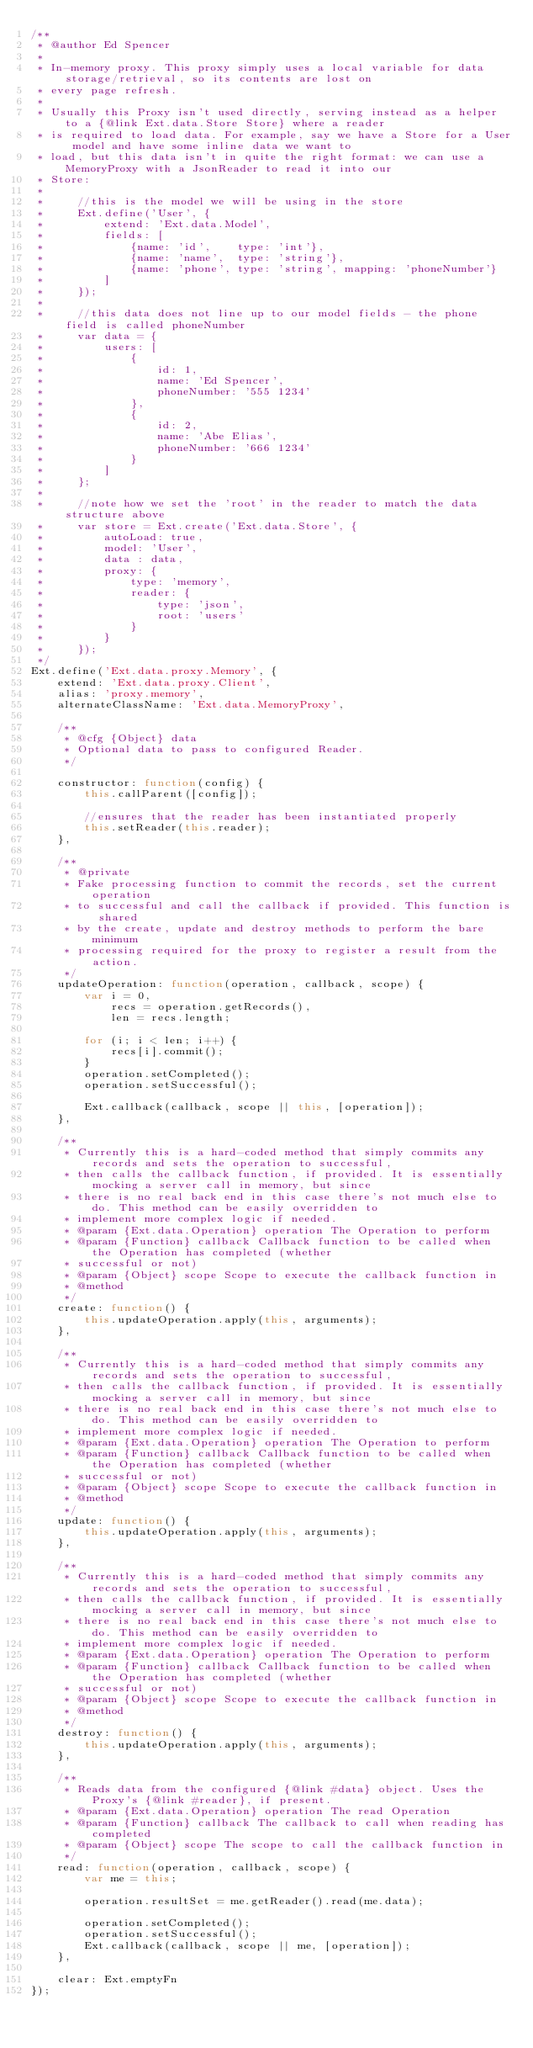Convert code to text. <code><loc_0><loc_0><loc_500><loc_500><_JavaScript_>/**
 * @author Ed Spencer
 *
 * In-memory proxy. This proxy simply uses a local variable for data storage/retrieval, so its contents are lost on
 * every page refresh.
 *
 * Usually this Proxy isn't used directly, serving instead as a helper to a {@link Ext.data.Store Store} where a reader
 * is required to load data. For example, say we have a Store for a User model and have some inline data we want to
 * load, but this data isn't in quite the right format: we can use a MemoryProxy with a JsonReader to read it into our
 * Store:
 *
 *     //this is the model we will be using in the store
 *     Ext.define('User', {
 *         extend: 'Ext.data.Model',
 *         fields: [
 *             {name: 'id',    type: 'int'},
 *             {name: 'name',  type: 'string'},
 *             {name: 'phone', type: 'string', mapping: 'phoneNumber'}
 *         ]
 *     });
 *
 *     //this data does not line up to our model fields - the phone field is called phoneNumber
 *     var data = {
 *         users: [
 *             {
 *                 id: 1,
 *                 name: 'Ed Spencer',
 *                 phoneNumber: '555 1234'
 *             },
 *             {
 *                 id: 2,
 *                 name: 'Abe Elias',
 *                 phoneNumber: '666 1234'
 *             }
 *         ]
 *     };
 *
 *     //note how we set the 'root' in the reader to match the data structure above
 *     var store = Ext.create('Ext.data.Store', {
 *         autoLoad: true,
 *         model: 'User',
 *         data : data,
 *         proxy: {
 *             type: 'memory',
 *             reader: {
 *                 type: 'json',
 *                 root: 'users'
 *             }
 *         }
 *     });
 */
Ext.define('Ext.data.proxy.Memory', {
    extend: 'Ext.data.proxy.Client',
    alias: 'proxy.memory',
    alternateClassName: 'Ext.data.MemoryProxy',

    /**
     * @cfg {Object} data
     * Optional data to pass to configured Reader.
     */

    constructor: function(config) {
        this.callParent([config]);

        //ensures that the reader has been instantiated properly
        this.setReader(this.reader);
    },
    
    /**
     * @private
     * Fake processing function to commit the records, set the current operation
     * to successful and call the callback if provided. This function is shared
     * by the create, update and destroy methods to perform the bare minimum
     * processing required for the proxy to register a result from the action.
     */
    updateOperation: function(operation, callback, scope) {
        var i = 0,
            recs = operation.getRecords(),
            len = recs.length;
            
        for (i; i < len; i++) {
            recs[i].commit();
        }
        operation.setCompleted();
        operation.setSuccessful();
        
        Ext.callback(callback, scope || this, [operation]);
    },
    
    /**
     * Currently this is a hard-coded method that simply commits any records and sets the operation to successful,
     * then calls the callback function, if provided. It is essentially mocking a server call in memory, but since
     * there is no real back end in this case there's not much else to do. This method can be easily overridden to 
     * implement more complex logic if needed.
     * @param {Ext.data.Operation} operation The Operation to perform
     * @param {Function} callback Callback function to be called when the Operation has completed (whether
     * successful or not)
     * @param {Object} scope Scope to execute the callback function in
     * @method
     */
    create: function() {
        this.updateOperation.apply(this, arguments);
    },
    
    /**
     * Currently this is a hard-coded method that simply commits any records and sets the operation to successful,
     * then calls the callback function, if provided. It is essentially mocking a server call in memory, but since
     * there is no real back end in this case there's not much else to do. This method can be easily overridden to 
     * implement more complex logic if needed.
     * @param {Ext.data.Operation} operation The Operation to perform
     * @param {Function} callback Callback function to be called when the Operation has completed (whether
     * successful or not)
     * @param {Object} scope Scope to execute the callback function in
     * @method
     */
    update: function() {
        this.updateOperation.apply(this, arguments);
    },
    
    /**
     * Currently this is a hard-coded method that simply commits any records and sets the operation to successful,
     * then calls the callback function, if provided. It is essentially mocking a server call in memory, but since
     * there is no real back end in this case there's not much else to do. This method can be easily overridden to 
     * implement more complex logic if needed.
     * @param {Ext.data.Operation} operation The Operation to perform
     * @param {Function} callback Callback function to be called when the Operation has completed (whether
     * successful or not)
     * @param {Object} scope Scope to execute the callback function in
     * @method
     */
    destroy: function() {
        this.updateOperation.apply(this, arguments);
    },

    /**
     * Reads data from the configured {@link #data} object. Uses the Proxy's {@link #reader}, if present.
     * @param {Ext.data.Operation} operation The read Operation
     * @param {Function} callback The callback to call when reading has completed
     * @param {Object} scope The scope to call the callback function in
     */
    read: function(operation, callback, scope) {
        var me = this;

        operation.resultSet = me.getReader().read(me.data);

        operation.setCompleted();
        operation.setSuccessful();
        Ext.callback(callback, scope || me, [operation]);
    },

    clear: Ext.emptyFn
});
</code> 